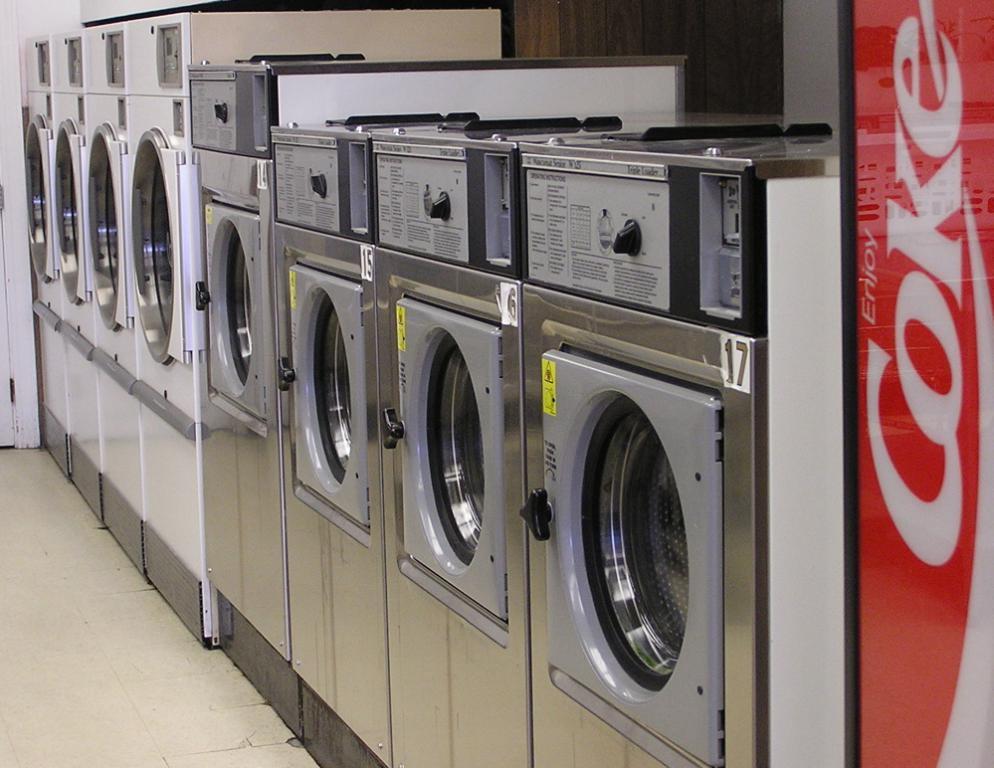Can you describe this image briefly? This picture contains many clothes dryers and washing machines. Beside that, we see a white color wall. On the right corner of the picture, we see a red board on which "COKE" is written. This picture might be clicked in a showroom. 